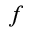Convert formula to latex. <formula><loc_0><loc_0><loc_500><loc_500>_ { f }</formula> 